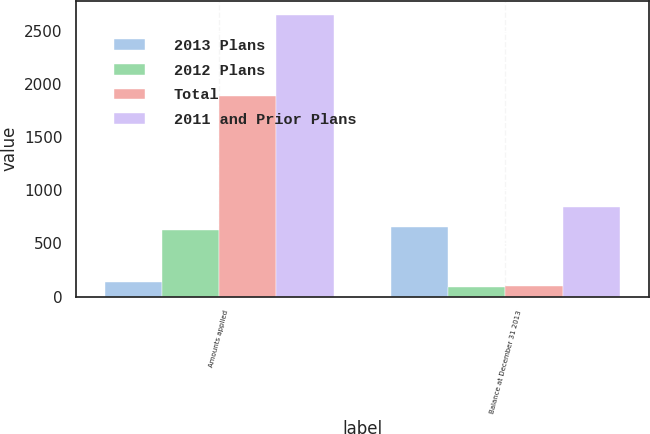Convert chart. <chart><loc_0><loc_0><loc_500><loc_500><stacked_bar_chart><ecel><fcel>Amounts applied<fcel>Balance at December 31 2013<nl><fcel>2013 Plans<fcel>136<fcel>656<nl><fcel>2012 Plans<fcel>626<fcel>92<nl><fcel>Total<fcel>1887<fcel>98<nl><fcel>2011 and Prior Plans<fcel>2649<fcel>846<nl></chart> 